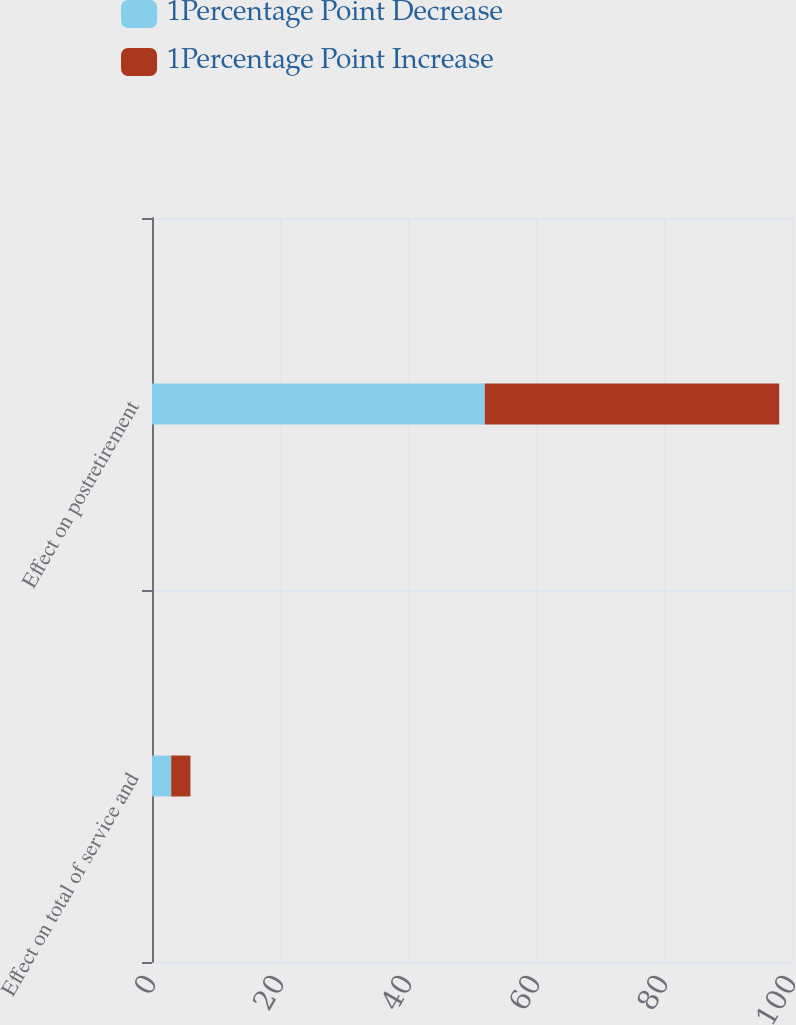Convert chart. <chart><loc_0><loc_0><loc_500><loc_500><stacked_bar_chart><ecel><fcel>Effect on total of service and<fcel>Effect on postretirement<nl><fcel>1Percentage Point Decrease<fcel>3<fcel>52<nl><fcel>1Percentage Point Increase<fcel>3<fcel>46<nl></chart> 